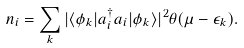<formula> <loc_0><loc_0><loc_500><loc_500>n _ { i } = \sum _ { k } | \langle \phi _ { k } | a _ { i } ^ { \dag } a _ { i } | \phi _ { k } \rangle | ^ { 2 } \theta ( \mu - \epsilon _ { k } ) .</formula> 